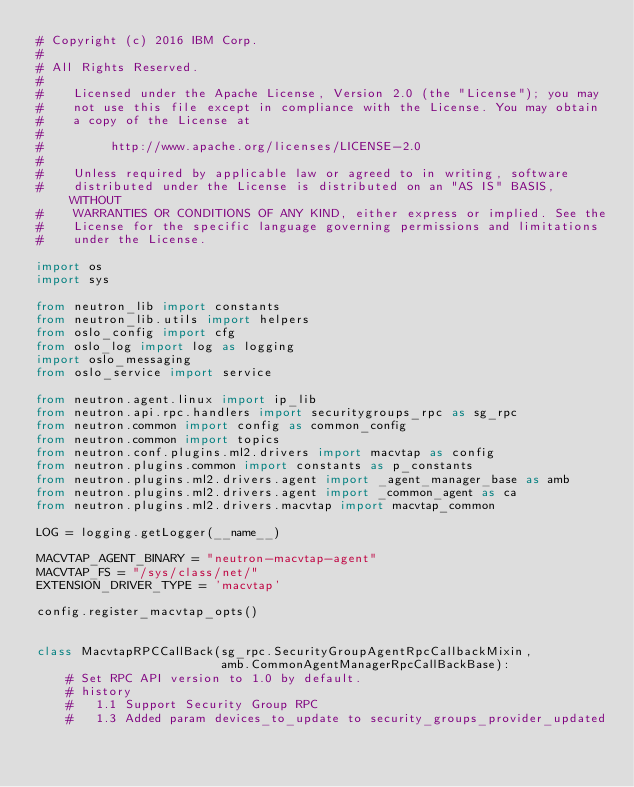Convert code to text. <code><loc_0><loc_0><loc_500><loc_500><_Python_># Copyright (c) 2016 IBM Corp.
#
# All Rights Reserved.
#
#    Licensed under the Apache License, Version 2.0 (the "License"); you may
#    not use this file except in compliance with the License. You may obtain
#    a copy of the License at
#
#         http://www.apache.org/licenses/LICENSE-2.0
#
#    Unless required by applicable law or agreed to in writing, software
#    distributed under the License is distributed on an "AS IS" BASIS, WITHOUT
#    WARRANTIES OR CONDITIONS OF ANY KIND, either express or implied. See the
#    License for the specific language governing permissions and limitations
#    under the License.

import os
import sys

from neutron_lib import constants
from neutron_lib.utils import helpers
from oslo_config import cfg
from oslo_log import log as logging
import oslo_messaging
from oslo_service import service

from neutron.agent.linux import ip_lib
from neutron.api.rpc.handlers import securitygroups_rpc as sg_rpc
from neutron.common import config as common_config
from neutron.common import topics
from neutron.conf.plugins.ml2.drivers import macvtap as config
from neutron.plugins.common import constants as p_constants
from neutron.plugins.ml2.drivers.agent import _agent_manager_base as amb
from neutron.plugins.ml2.drivers.agent import _common_agent as ca
from neutron.plugins.ml2.drivers.macvtap import macvtap_common

LOG = logging.getLogger(__name__)

MACVTAP_AGENT_BINARY = "neutron-macvtap-agent"
MACVTAP_FS = "/sys/class/net/"
EXTENSION_DRIVER_TYPE = 'macvtap'

config.register_macvtap_opts()


class MacvtapRPCCallBack(sg_rpc.SecurityGroupAgentRpcCallbackMixin,
                         amb.CommonAgentManagerRpcCallBackBase):
    # Set RPC API version to 1.0 by default.
    # history
    #   1.1 Support Security Group RPC
    #   1.3 Added param devices_to_update to security_groups_provider_updated</code> 